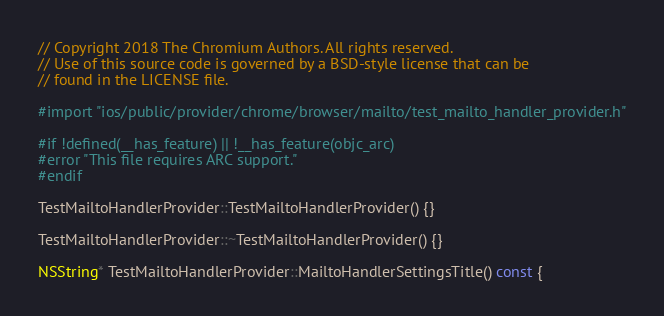Convert code to text. <code><loc_0><loc_0><loc_500><loc_500><_ObjectiveC_>// Copyright 2018 The Chromium Authors. All rights reserved.
// Use of this source code is governed by a BSD-style license that can be
// found in the LICENSE file.

#import "ios/public/provider/chrome/browser/mailto/test_mailto_handler_provider.h"

#if !defined(__has_feature) || !__has_feature(objc_arc)
#error "This file requires ARC support."
#endif

TestMailtoHandlerProvider::TestMailtoHandlerProvider() {}

TestMailtoHandlerProvider::~TestMailtoHandlerProvider() {}

NSString* TestMailtoHandlerProvider::MailtoHandlerSettingsTitle() const {</code> 